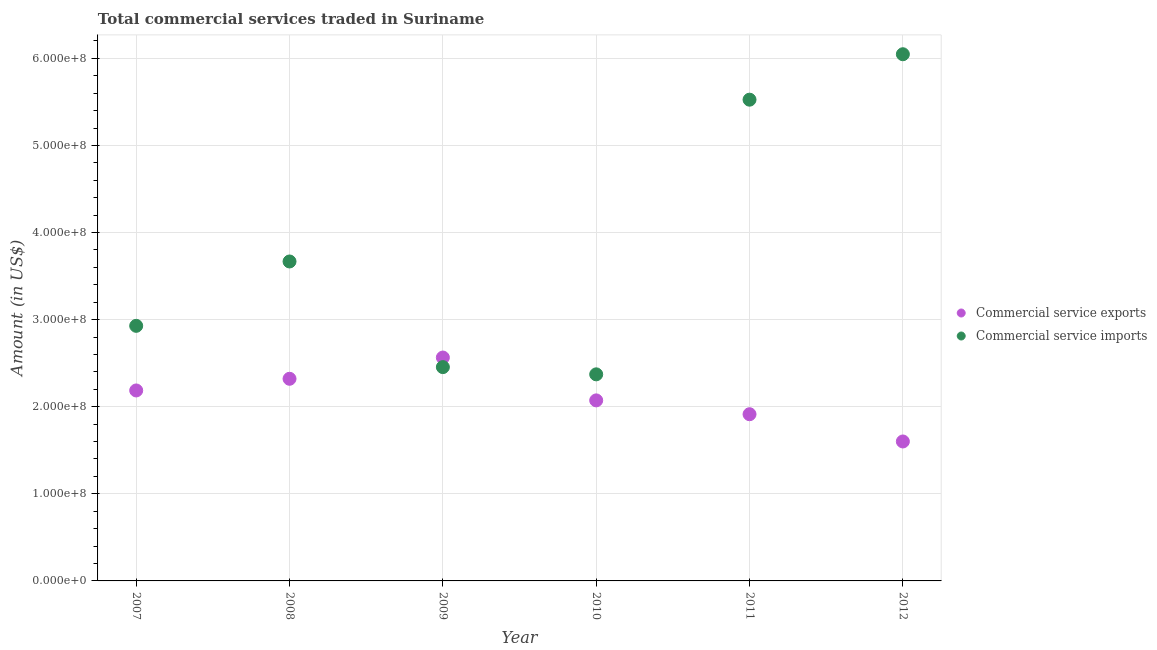Is the number of dotlines equal to the number of legend labels?
Give a very brief answer. Yes. What is the amount of commercial service exports in 2010?
Provide a succinct answer. 2.07e+08. Across all years, what is the maximum amount of commercial service imports?
Your response must be concise. 6.05e+08. Across all years, what is the minimum amount of commercial service exports?
Give a very brief answer. 1.60e+08. In which year was the amount of commercial service imports maximum?
Ensure brevity in your answer.  2012. What is the total amount of commercial service imports in the graph?
Ensure brevity in your answer.  2.30e+09. What is the difference between the amount of commercial service imports in 2007 and that in 2010?
Offer a very short reply. 5.57e+07. What is the difference between the amount of commercial service imports in 2010 and the amount of commercial service exports in 2009?
Provide a short and direct response. -1.93e+07. What is the average amount of commercial service imports per year?
Your response must be concise. 3.83e+08. In the year 2007, what is the difference between the amount of commercial service exports and amount of commercial service imports?
Offer a very short reply. -7.42e+07. What is the ratio of the amount of commercial service exports in 2008 to that in 2009?
Give a very brief answer. 0.9. Is the amount of commercial service imports in 2011 less than that in 2012?
Keep it short and to the point. Yes. Is the difference between the amount of commercial service imports in 2010 and 2012 greater than the difference between the amount of commercial service exports in 2010 and 2012?
Offer a terse response. No. What is the difference between the highest and the second highest amount of commercial service exports?
Offer a terse response. 2.44e+07. What is the difference between the highest and the lowest amount of commercial service exports?
Offer a very short reply. 9.64e+07. Is the sum of the amount of commercial service imports in 2007 and 2012 greater than the maximum amount of commercial service exports across all years?
Your response must be concise. Yes. Does the amount of commercial service exports monotonically increase over the years?
Give a very brief answer. No. Is the amount of commercial service exports strictly less than the amount of commercial service imports over the years?
Give a very brief answer. No. How many dotlines are there?
Provide a succinct answer. 2. How many years are there in the graph?
Your response must be concise. 6. Are the values on the major ticks of Y-axis written in scientific E-notation?
Your answer should be very brief. Yes. Does the graph contain any zero values?
Your answer should be compact. No. Does the graph contain grids?
Ensure brevity in your answer.  Yes. Where does the legend appear in the graph?
Make the answer very short. Center right. How many legend labels are there?
Give a very brief answer. 2. How are the legend labels stacked?
Your answer should be compact. Vertical. What is the title of the graph?
Give a very brief answer. Total commercial services traded in Suriname. Does "RDB nonconcessional" appear as one of the legend labels in the graph?
Make the answer very short. No. What is the Amount (in US$) in Commercial service exports in 2007?
Offer a terse response. 2.19e+08. What is the Amount (in US$) of Commercial service imports in 2007?
Your answer should be compact. 2.93e+08. What is the Amount (in US$) in Commercial service exports in 2008?
Ensure brevity in your answer.  2.32e+08. What is the Amount (in US$) of Commercial service imports in 2008?
Give a very brief answer. 3.67e+08. What is the Amount (in US$) of Commercial service exports in 2009?
Give a very brief answer. 2.56e+08. What is the Amount (in US$) of Commercial service imports in 2009?
Provide a succinct answer. 2.46e+08. What is the Amount (in US$) of Commercial service exports in 2010?
Provide a succinct answer. 2.07e+08. What is the Amount (in US$) of Commercial service imports in 2010?
Ensure brevity in your answer.  2.37e+08. What is the Amount (in US$) in Commercial service exports in 2011?
Make the answer very short. 1.91e+08. What is the Amount (in US$) in Commercial service imports in 2011?
Your answer should be very brief. 5.53e+08. What is the Amount (in US$) in Commercial service exports in 2012?
Your response must be concise. 1.60e+08. What is the Amount (in US$) in Commercial service imports in 2012?
Your response must be concise. 6.05e+08. Across all years, what is the maximum Amount (in US$) of Commercial service exports?
Your answer should be compact. 2.56e+08. Across all years, what is the maximum Amount (in US$) of Commercial service imports?
Ensure brevity in your answer.  6.05e+08. Across all years, what is the minimum Amount (in US$) in Commercial service exports?
Your answer should be very brief. 1.60e+08. Across all years, what is the minimum Amount (in US$) in Commercial service imports?
Give a very brief answer. 2.37e+08. What is the total Amount (in US$) of Commercial service exports in the graph?
Your answer should be very brief. 1.27e+09. What is the total Amount (in US$) of Commercial service imports in the graph?
Give a very brief answer. 2.30e+09. What is the difference between the Amount (in US$) in Commercial service exports in 2007 and that in 2008?
Provide a succinct answer. -1.34e+07. What is the difference between the Amount (in US$) of Commercial service imports in 2007 and that in 2008?
Your answer should be compact. -7.39e+07. What is the difference between the Amount (in US$) in Commercial service exports in 2007 and that in 2009?
Make the answer very short. -3.78e+07. What is the difference between the Amount (in US$) of Commercial service imports in 2007 and that in 2009?
Give a very brief answer. 4.74e+07. What is the difference between the Amount (in US$) in Commercial service exports in 2007 and that in 2010?
Provide a short and direct response. 1.14e+07. What is the difference between the Amount (in US$) of Commercial service imports in 2007 and that in 2010?
Your answer should be compact. 5.57e+07. What is the difference between the Amount (in US$) in Commercial service exports in 2007 and that in 2011?
Offer a very short reply. 2.73e+07. What is the difference between the Amount (in US$) of Commercial service imports in 2007 and that in 2011?
Make the answer very short. -2.60e+08. What is the difference between the Amount (in US$) of Commercial service exports in 2007 and that in 2012?
Ensure brevity in your answer.  5.86e+07. What is the difference between the Amount (in US$) in Commercial service imports in 2007 and that in 2012?
Your response must be concise. -3.12e+08. What is the difference between the Amount (in US$) of Commercial service exports in 2008 and that in 2009?
Provide a short and direct response. -2.44e+07. What is the difference between the Amount (in US$) of Commercial service imports in 2008 and that in 2009?
Make the answer very short. 1.21e+08. What is the difference between the Amount (in US$) in Commercial service exports in 2008 and that in 2010?
Your answer should be very brief. 2.48e+07. What is the difference between the Amount (in US$) in Commercial service imports in 2008 and that in 2010?
Keep it short and to the point. 1.30e+08. What is the difference between the Amount (in US$) of Commercial service exports in 2008 and that in 2011?
Keep it short and to the point. 4.07e+07. What is the difference between the Amount (in US$) of Commercial service imports in 2008 and that in 2011?
Keep it short and to the point. -1.86e+08. What is the difference between the Amount (in US$) in Commercial service exports in 2008 and that in 2012?
Your response must be concise. 7.20e+07. What is the difference between the Amount (in US$) in Commercial service imports in 2008 and that in 2012?
Keep it short and to the point. -2.38e+08. What is the difference between the Amount (in US$) in Commercial service exports in 2009 and that in 2010?
Ensure brevity in your answer.  4.92e+07. What is the difference between the Amount (in US$) of Commercial service imports in 2009 and that in 2010?
Your answer should be very brief. 8.30e+06. What is the difference between the Amount (in US$) in Commercial service exports in 2009 and that in 2011?
Ensure brevity in your answer.  6.51e+07. What is the difference between the Amount (in US$) of Commercial service imports in 2009 and that in 2011?
Keep it short and to the point. -3.07e+08. What is the difference between the Amount (in US$) in Commercial service exports in 2009 and that in 2012?
Give a very brief answer. 9.64e+07. What is the difference between the Amount (in US$) in Commercial service imports in 2009 and that in 2012?
Give a very brief answer. -3.59e+08. What is the difference between the Amount (in US$) in Commercial service exports in 2010 and that in 2011?
Provide a short and direct response. 1.59e+07. What is the difference between the Amount (in US$) in Commercial service imports in 2010 and that in 2011?
Provide a short and direct response. -3.15e+08. What is the difference between the Amount (in US$) in Commercial service exports in 2010 and that in 2012?
Provide a succinct answer. 4.72e+07. What is the difference between the Amount (in US$) of Commercial service imports in 2010 and that in 2012?
Offer a very short reply. -3.68e+08. What is the difference between the Amount (in US$) of Commercial service exports in 2011 and that in 2012?
Your answer should be very brief. 3.13e+07. What is the difference between the Amount (in US$) in Commercial service imports in 2011 and that in 2012?
Provide a succinct answer. -5.22e+07. What is the difference between the Amount (in US$) of Commercial service exports in 2007 and the Amount (in US$) of Commercial service imports in 2008?
Your response must be concise. -1.48e+08. What is the difference between the Amount (in US$) of Commercial service exports in 2007 and the Amount (in US$) of Commercial service imports in 2009?
Your response must be concise. -2.68e+07. What is the difference between the Amount (in US$) of Commercial service exports in 2007 and the Amount (in US$) of Commercial service imports in 2010?
Offer a very short reply. -1.85e+07. What is the difference between the Amount (in US$) of Commercial service exports in 2007 and the Amount (in US$) of Commercial service imports in 2011?
Provide a short and direct response. -3.34e+08. What is the difference between the Amount (in US$) of Commercial service exports in 2007 and the Amount (in US$) of Commercial service imports in 2012?
Provide a short and direct response. -3.86e+08. What is the difference between the Amount (in US$) in Commercial service exports in 2008 and the Amount (in US$) in Commercial service imports in 2009?
Keep it short and to the point. -1.34e+07. What is the difference between the Amount (in US$) of Commercial service exports in 2008 and the Amount (in US$) of Commercial service imports in 2010?
Keep it short and to the point. -5.10e+06. What is the difference between the Amount (in US$) in Commercial service exports in 2008 and the Amount (in US$) in Commercial service imports in 2011?
Give a very brief answer. -3.20e+08. What is the difference between the Amount (in US$) of Commercial service exports in 2008 and the Amount (in US$) of Commercial service imports in 2012?
Provide a succinct answer. -3.73e+08. What is the difference between the Amount (in US$) of Commercial service exports in 2009 and the Amount (in US$) of Commercial service imports in 2010?
Give a very brief answer. 1.93e+07. What is the difference between the Amount (in US$) of Commercial service exports in 2009 and the Amount (in US$) of Commercial service imports in 2011?
Offer a very short reply. -2.96e+08. What is the difference between the Amount (in US$) of Commercial service exports in 2009 and the Amount (in US$) of Commercial service imports in 2012?
Your answer should be compact. -3.48e+08. What is the difference between the Amount (in US$) in Commercial service exports in 2010 and the Amount (in US$) in Commercial service imports in 2011?
Your answer should be very brief. -3.45e+08. What is the difference between the Amount (in US$) in Commercial service exports in 2010 and the Amount (in US$) in Commercial service imports in 2012?
Provide a short and direct response. -3.97e+08. What is the difference between the Amount (in US$) of Commercial service exports in 2011 and the Amount (in US$) of Commercial service imports in 2012?
Keep it short and to the point. -4.13e+08. What is the average Amount (in US$) in Commercial service exports per year?
Ensure brevity in your answer.  2.11e+08. What is the average Amount (in US$) of Commercial service imports per year?
Provide a succinct answer. 3.83e+08. In the year 2007, what is the difference between the Amount (in US$) of Commercial service exports and Amount (in US$) of Commercial service imports?
Ensure brevity in your answer.  -7.42e+07. In the year 2008, what is the difference between the Amount (in US$) in Commercial service exports and Amount (in US$) in Commercial service imports?
Ensure brevity in your answer.  -1.35e+08. In the year 2009, what is the difference between the Amount (in US$) in Commercial service exports and Amount (in US$) in Commercial service imports?
Make the answer very short. 1.10e+07. In the year 2010, what is the difference between the Amount (in US$) in Commercial service exports and Amount (in US$) in Commercial service imports?
Your answer should be compact. -2.99e+07. In the year 2011, what is the difference between the Amount (in US$) in Commercial service exports and Amount (in US$) in Commercial service imports?
Offer a terse response. -3.61e+08. In the year 2012, what is the difference between the Amount (in US$) in Commercial service exports and Amount (in US$) in Commercial service imports?
Keep it short and to the point. -4.45e+08. What is the ratio of the Amount (in US$) in Commercial service exports in 2007 to that in 2008?
Your answer should be very brief. 0.94. What is the ratio of the Amount (in US$) of Commercial service imports in 2007 to that in 2008?
Your answer should be compact. 0.8. What is the ratio of the Amount (in US$) in Commercial service exports in 2007 to that in 2009?
Your answer should be compact. 0.85. What is the ratio of the Amount (in US$) in Commercial service imports in 2007 to that in 2009?
Keep it short and to the point. 1.19. What is the ratio of the Amount (in US$) of Commercial service exports in 2007 to that in 2010?
Your answer should be very brief. 1.05. What is the ratio of the Amount (in US$) of Commercial service imports in 2007 to that in 2010?
Provide a succinct answer. 1.23. What is the ratio of the Amount (in US$) in Commercial service exports in 2007 to that in 2011?
Keep it short and to the point. 1.14. What is the ratio of the Amount (in US$) in Commercial service imports in 2007 to that in 2011?
Make the answer very short. 0.53. What is the ratio of the Amount (in US$) in Commercial service exports in 2007 to that in 2012?
Ensure brevity in your answer.  1.37. What is the ratio of the Amount (in US$) in Commercial service imports in 2007 to that in 2012?
Offer a terse response. 0.48. What is the ratio of the Amount (in US$) of Commercial service exports in 2008 to that in 2009?
Your answer should be very brief. 0.9. What is the ratio of the Amount (in US$) in Commercial service imports in 2008 to that in 2009?
Your response must be concise. 1.49. What is the ratio of the Amount (in US$) of Commercial service exports in 2008 to that in 2010?
Your response must be concise. 1.12. What is the ratio of the Amount (in US$) in Commercial service imports in 2008 to that in 2010?
Your response must be concise. 1.55. What is the ratio of the Amount (in US$) in Commercial service exports in 2008 to that in 2011?
Make the answer very short. 1.21. What is the ratio of the Amount (in US$) of Commercial service imports in 2008 to that in 2011?
Keep it short and to the point. 0.66. What is the ratio of the Amount (in US$) in Commercial service exports in 2008 to that in 2012?
Ensure brevity in your answer.  1.45. What is the ratio of the Amount (in US$) in Commercial service imports in 2008 to that in 2012?
Your answer should be very brief. 0.61. What is the ratio of the Amount (in US$) of Commercial service exports in 2009 to that in 2010?
Provide a succinct answer. 1.24. What is the ratio of the Amount (in US$) in Commercial service imports in 2009 to that in 2010?
Your answer should be compact. 1.03. What is the ratio of the Amount (in US$) in Commercial service exports in 2009 to that in 2011?
Make the answer very short. 1.34. What is the ratio of the Amount (in US$) in Commercial service imports in 2009 to that in 2011?
Your response must be concise. 0.44. What is the ratio of the Amount (in US$) in Commercial service exports in 2009 to that in 2012?
Your response must be concise. 1.6. What is the ratio of the Amount (in US$) in Commercial service imports in 2009 to that in 2012?
Keep it short and to the point. 0.41. What is the ratio of the Amount (in US$) of Commercial service exports in 2010 to that in 2011?
Provide a succinct answer. 1.08. What is the ratio of the Amount (in US$) of Commercial service imports in 2010 to that in 2011?
Your response must be concise. 0.43. What is the ratio of the Amount (in US$) of Commercial service exports in 2010 to that in 2012?
Offer a terse response. 1.29. What is the ratio of the Amount (in US$) of Commercial service imports in 2010 to that in 2012?
Offer a terse response. 0.39. What is the ratio of the Amount (in US$) in Commercial service exports in 2011 to that in 2012?
Keep it short and to the point. 1.2. What is the ratio of the Amount (in US$) of Commercial service imports in 2011 to that in 2012?
Offer a very short reply. 0.91. What is the difference between the highest and the second highest Amount (in US$) in Commercial service exports?
Provide a short and direct response. 2.44e+07. What is the difference between the highest and the second highest Amount (in US$) in Commercial service imports?
Ensure brevity in your answer.  5.22e+07. What is the difference between the highest and the lowest Amount (in US$) in Commercial service exports?
Provide a short and direct response. 9.64e+07. What is the difference between the highest and the lowest Amount (in US$) of Commercial service imports?
Your answer should be very brief. 3.68e+08. 